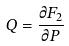<formula> <loc_0><loc_0><loc_500><loc_500>Q = \frac { \partial F _ { 2 } } { \partial P }</formula> 